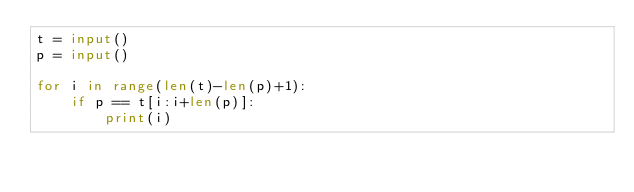<code> <loc_0><loc_0><loc_500><loc_500><_Python_>t = input()
p = input()

for i in range(len(t)-len(p)+1):
    if p == t[i:i+len(p)]:
        print(i)
</code> 